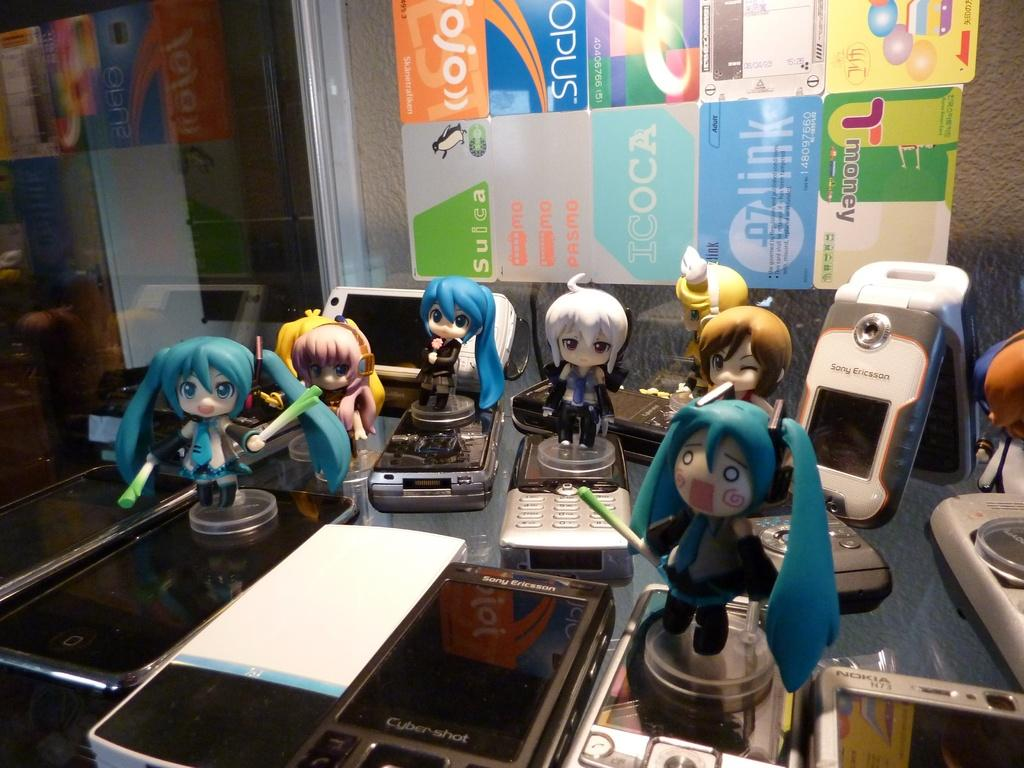What type of objects can be seen in the image? There are many mobiles and dolls in the image. Where are these objects located? The objects are kept on a desk. What can be seen on the wall in the background? There are stickers on a wall in the background. What is to the left in the image? There is a mirror to the left in the image. What type of club can be seen in the image? There is no club present in the image; it features mobiles, dolls, a desk, stickers on a wall, and a mirror. What is the cow's interest in the image? There is no cow present in the image, so it is not possible to determine its interests. 